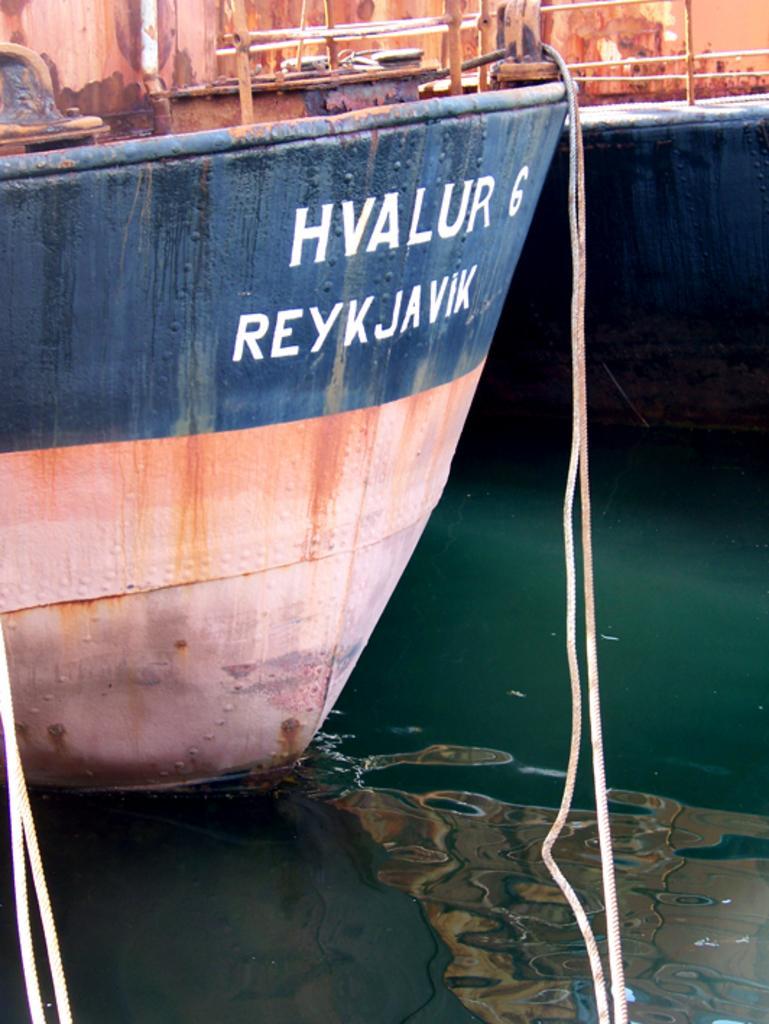Can you describe this image briefly? In the picture I can see ships on the water and ropes. I can also see something written on the ship. 